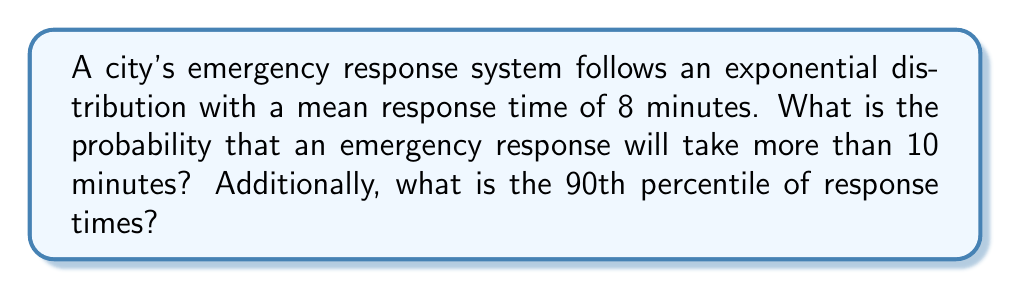Give your solution to this math problem. Let's approach this problem step-by-step:

1) For an exponential distribution, the probability density function is given by:

   $$f(x) = \lambda e^{-\lambda x}$$

   where $\lambda$ is the rate parameter.

2) The mean of an exponential distribution is $\frac{1}{\lambda}$. Given that the mean response time is 8 minutes:

   $$\frac{1}{\lambda} = 8$$
   $$\lambda = \frac{1}{8} = 0.125$$

3) To find the probability that a response will take more than 10 minutes, we need to calculate:

   $$P(X > 10) = 1 - P(X \leq 10)$$

4) For an exponential distribution:

   $$P(X \leq x) = 1 - e^{-\lambda x}$$

5) Therefore:

   $$P(X > 10) = 1 - (1 - e^{-0.125 * 10})$$
   $$= e^{-1.25} \approx 0.2865$$

6) For the 90th percentile, we need to find $x$ such that:

   $$P(X \leq x) = 0.90$$

7) Using the cumulative distribution function:

   $$1 - e^{-\lambda x} = 0.90$$
   $$e^{-\lambda x} = 0.10$$
   $$-\lambda x = \ln(0.10)$$
   $$x = -\frac{\ln(0.10)}{\lambda} = -\frac{\ln(0.10)}{0.125} \approx 18.43$$

Thus, the 90th percentile of response times is approximately 18.43 minutes.
Answer: P(X > 10) ≈ 0.2865, 90th percentile ≈ 18.43 minutes 